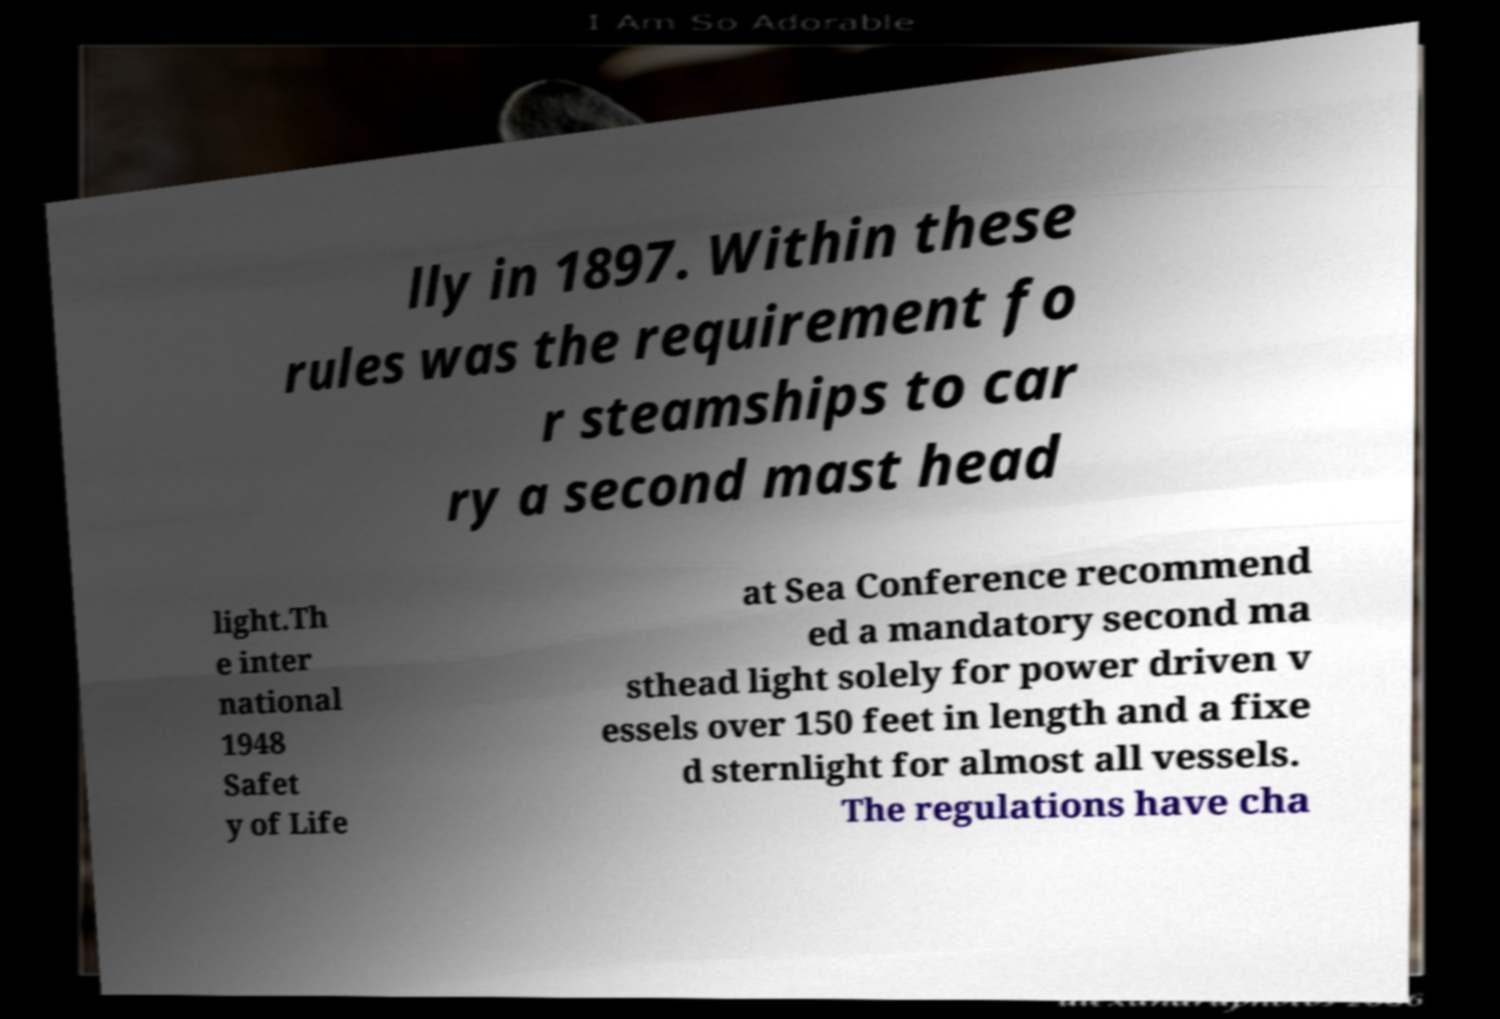What messages or text are displayed in this image? I need them in a readable, typed format. lly in 1897. Within these rules was the requirement fo r steamships to car ry a second mast head light.Th e inter national 1948 Safet y of Life at Sea Conference recommend ed a mandatory second ma sthead light solely for power driven v essels over 150 feet in length and a fixe d sternlight for almost all vessels. The regulations have cha 